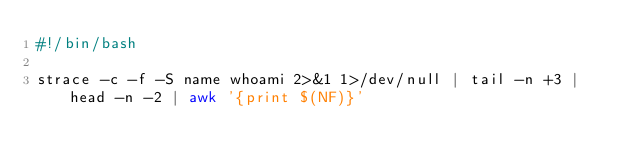<code> <loc_0><loc_0><loc_500><loc_500><_Bash_>#!/bin/bash

strace -c -f -S name whoami 2>&1 1>/dev/null | tail -n +3 | head -n -2 | awk '{print $(NF)}'
</code> 